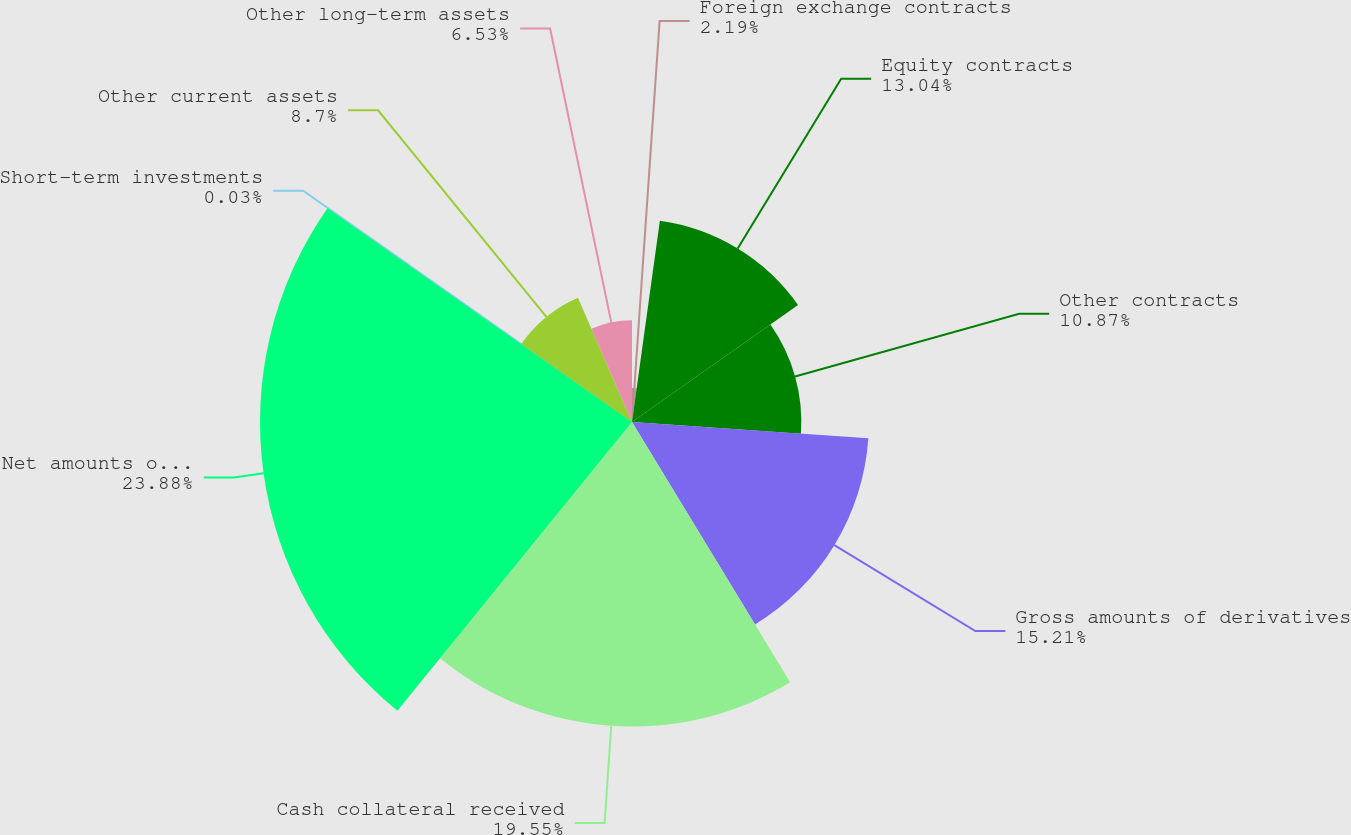Convert chart to OTSL. <chart><loc_0><loc_0><loc_500><loc_500><pie_chart><fcel>Foreign exchange contracts<fcel>Equity contracts<fcel>Other contracts<fcel>Gross amounts of derivatives<fcel>Cash collateral received<fcel>Net amounts of derivatives<fcel>Short-term investments<fcel>Other current assets<fcel>Other long-term assets<nl><fcel>2.19%<fcel>13.04%<fcel>10.87%<fcel>15.21%<fcel>19.55%<fcel>23.88%<fcel>0.03%<fcel>8.7%<fcel>6.53%<nl></chart> 